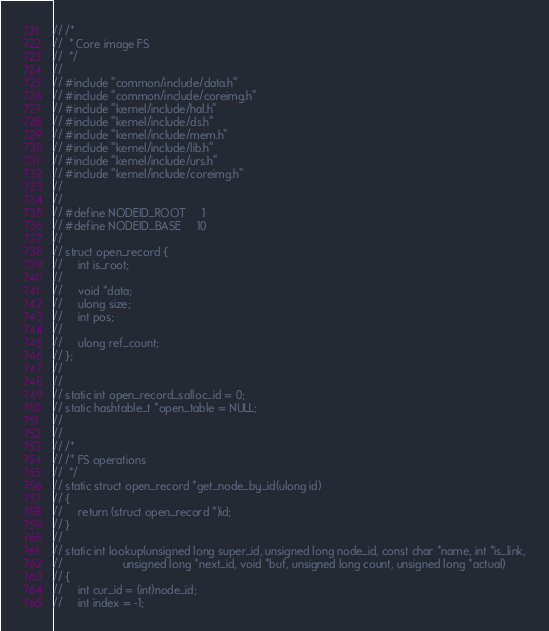Convert code to text. <code><loc_0><loc_0><loc_500><loc_500><_C_>// /*
//  * Core image FS
//  */
// 
// #include "common/include/data.h"
// #include "common/include/coreimg.h"
// #include "kernel/include/hal.h"
// #include "kernel/include/ds.h"
// #include "kernel/include/mem.h"
// #include "kernel/include/lib.h"
// #include "kernel/include/urs.h"
// #include "kernel/include/coreimg.h"
// 
// 
// #define NODEID_ROOT     1
// #define NODEID_BASE     10
// 
// struct open_record {
//     int is_root;
//     
//     void *data;
//     ulong size;
//     int pos;
//     
//     ulong ref_count;
// };
// 
// 
// static int open_record_salloc_id = 0;
// static hashtable_t *open_table = NULL;
// 
// 
// /*
// /* FS operations
//  */
// static struct open_record *get_node_by_id(ulong id)
// {
//     return (struct open_record *)id;
// }
// 
// static int lookup(unsigned long super_id, unsigned long node_id, const char *name, int *is_link,
//                   unsigned long *next_id, void *buf, unsigned long count, unsigned long *actual)
// {
//     int cur_id = (int)node_id;
//     int index = -1;</code> 